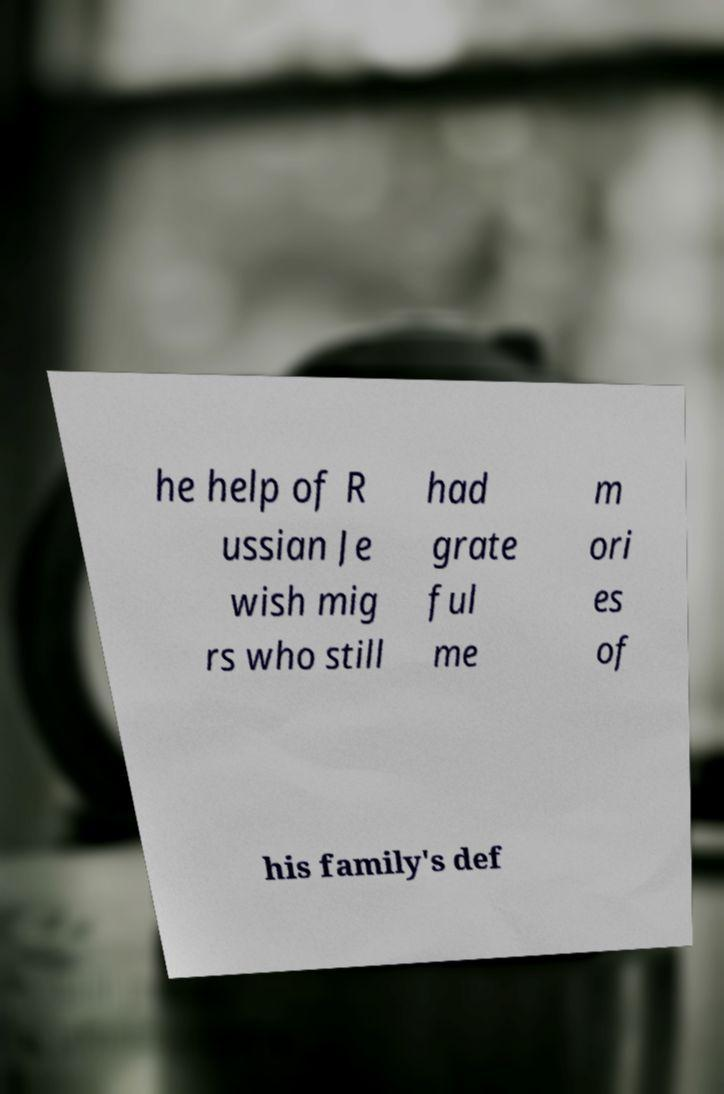For documentation purposes, I need the text within this image transcribed. Could you provide that? he help of R ussian Je wish mig rs who still had grate ful me m ori es of his family's def 